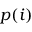Convert formula to latex. <formula><loc_0><loc_0><loc_500><loc_500>p ( i )</formula> 